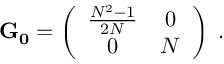Convert formula to latex. <formula><loc_0><loc_0><loc_500><loc_500>{ G _ { 0 } } = \left ( \begin{array} { c c } { { \frac { N ^ { 2 } - 1 } { 2 N } } } & { 0 } \\ { 0 } & { N } \end{array} \right ) \, .</formula> 